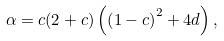<formula> <loc_0><loc_0><loc_500><loc_500>\alpha = c ( 2 + c ) \left ( \left ( 1 - c \right ) ^ { 2 } + 4 d \right ) ,</formula> 